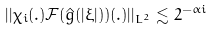Convert formula to latex. <formula><loc_0><loc_0><loc_500><loc_500>| | \chi _ { i } ( . ) { \mathcal { F } } ( \hat { g } ( | \xi | ) ) ( . ) | | _ { L ^ { 2 } } \lesssim 2 ^ { - \alpha i }</formula> 